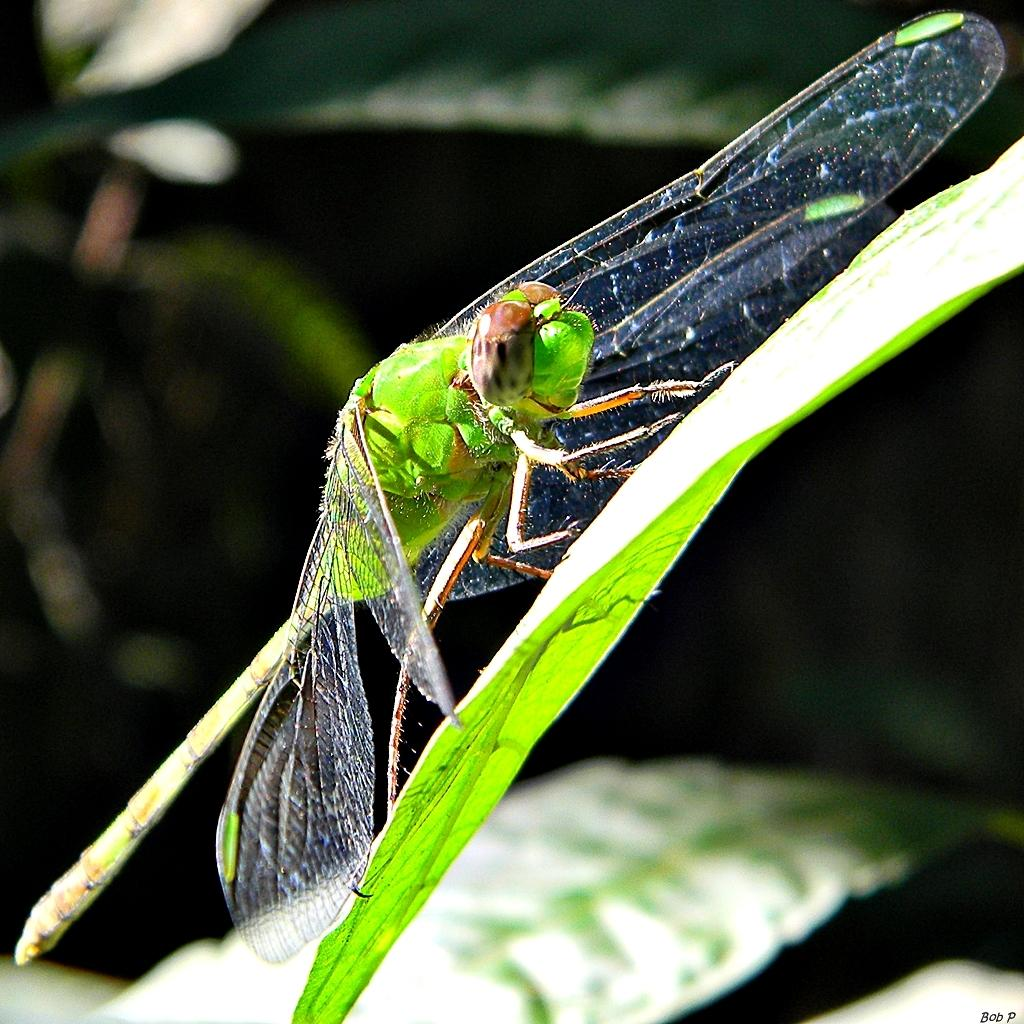What insect is present on a leaf in the image? There is a dragonfly on a leaf in the image. What can be observed about the background of the image? The background of the image is blurred. What type of vegetation is visible in the image? There are leaves visible in the image. Is there any additional information or marking on the image? Yes, there is a watermark on the right side bottom of the image. What type of writing can be seen on the leaf in the image? There is no writing present on the leaf in the image; it only features a dragonfly. 